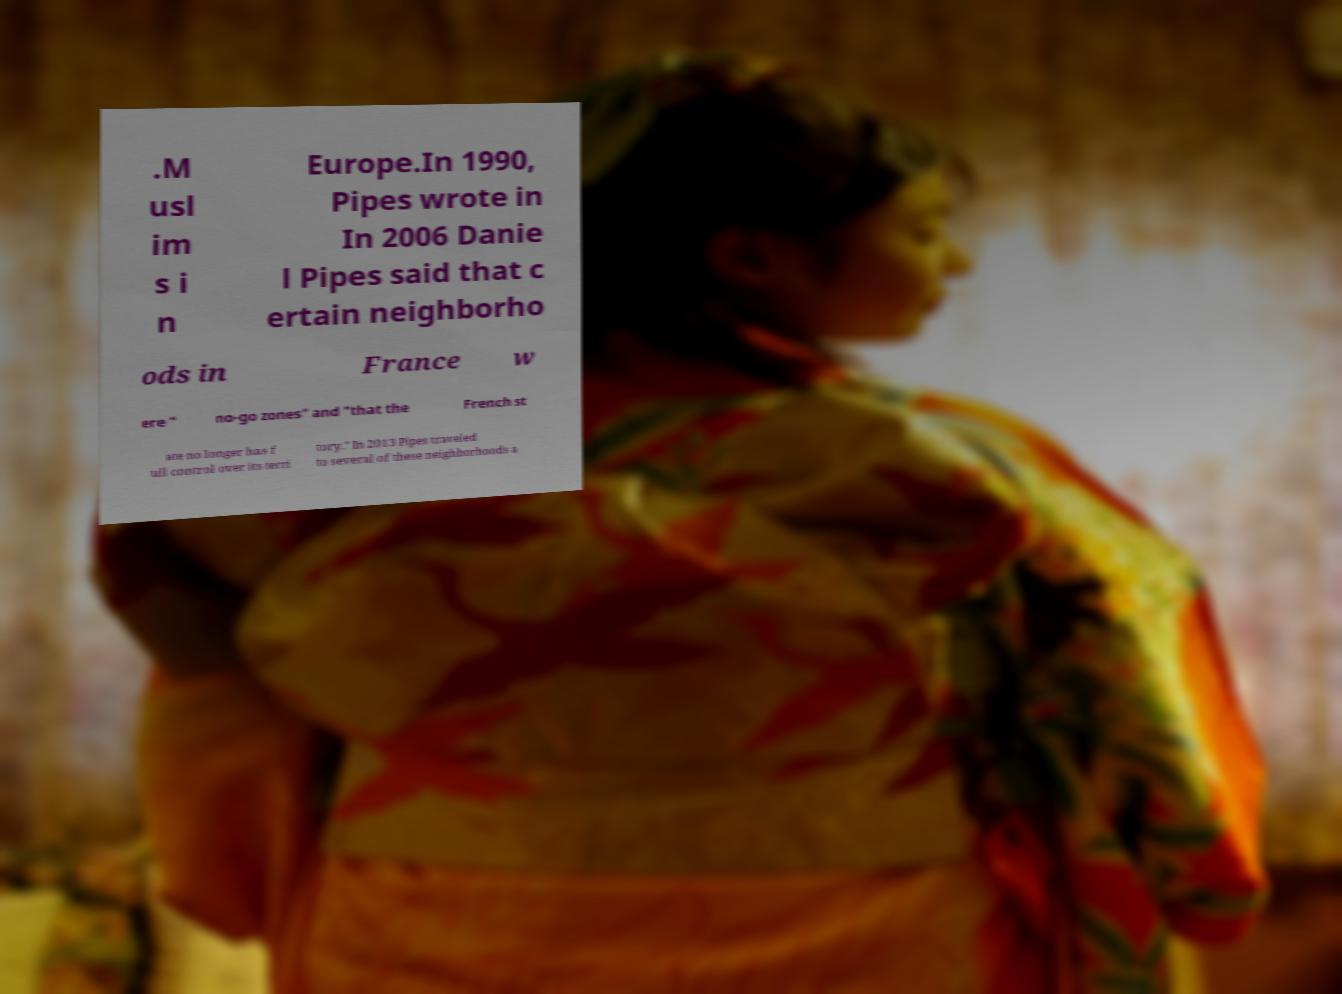Can you read and provide the text displayed in the image?This photo seems to have some interesting text. Can you extract and type it out for me? .M usl im s i n Europe.In 1990, Pipes wrote in In 2006 Danie l Pipes said that c ertain neighborho ods in France w ere " no-go zones" and "that the French st ate no longer has f ull control over its terri tory." In 2013 Pipes traveled to several of these neighborhoods a 